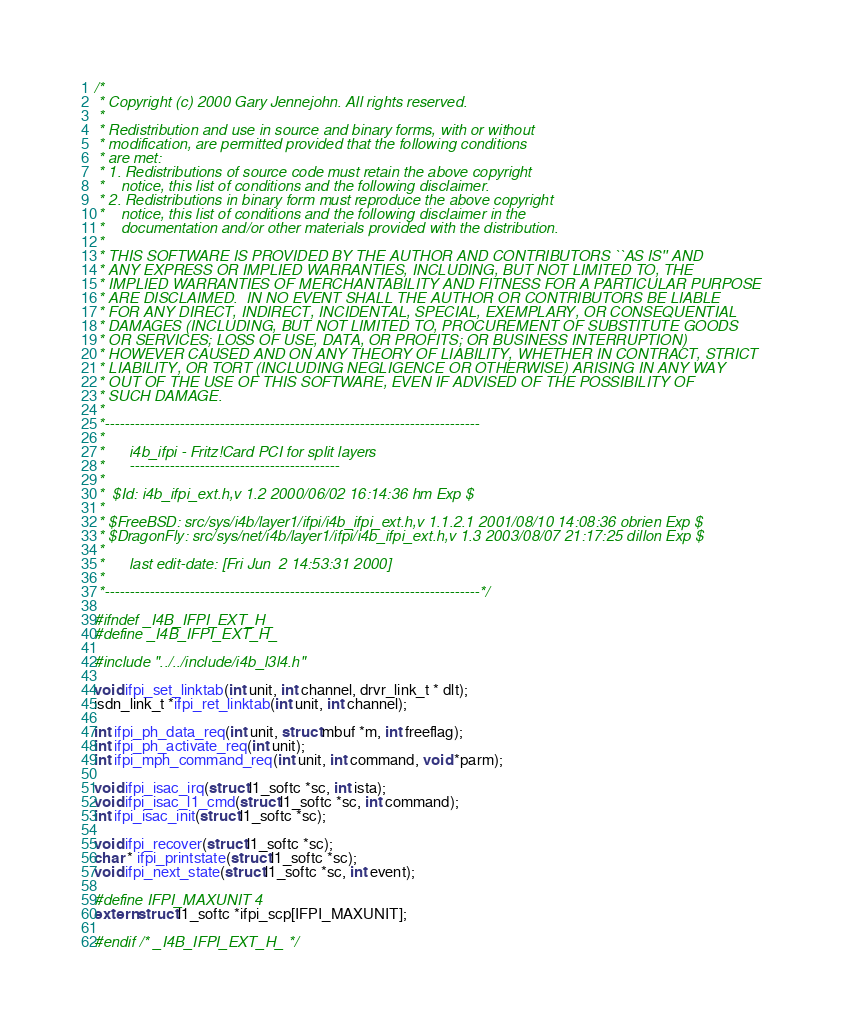Convert code to text. <code><loc_0><loc_0><loc_500><loc_500><_C_>/*
 * Copyright (c) 2000 Gary Jennejohn. All rights reserved.
 *
 * Redistribution and use in source and binary forms, with or without
 * modification, are permitted provided that the following conditions
 * are met:
 * 1. Redistributions of source code must retain the above copyright
 *    notice, this list of conditions and the following disclaimer.
 * 2. Redistributions in binary form must reproduce the above copyright
 *    notice, this list of conditions and the following disclaimer in the
 *    documentation and/or other materials provided with the distribution.
 *
 * THIS SOFTWARE IS PROVIDED BY THE AUTHOR AND CONTRIBUTORS ``AS IS'' AND
 * ANY EXPRESS OR IMPLIED WARRANTIES, INCLUDING, BUT NOT LIMITED TO, THE
 * IMPLIED WARRANTIES OF MERCHANTABILITY AND FITNESS FOR A PARTICULAR PURPOSE
 * ARE DISCLAIMED.  IN NO EVENT SHALL THE AUTHOR OR CONTRIBUTORS BE LIABLE
 * FOR ANY DIRECT, INDIRECT, INCIDENTAL, SPECIAL, EXEMPLARY, OR CONSEQUENTIAL
 * DAMAGES (INCLUDING, BUT NOT LIMITED TO, PROCUREMENT OF SUBSTITUTE GOODS
 * OR SERVICES; LOSS OF USE, DATA, OR PROFITS; OR BUSINESS INTERRUPTION)
 * HOWEVER CAUSED AND ON ANY THEORY OF LIABILITY, WHETHER IN CONTRACT, STRICT
 * LIABILITY, OR TORT (INCLUDING NEGLIGENCE OR OTHERWISE) ARISING IN ANY WAY
 * OUT OF THE USE OF THIS SOFTWARE, EVEN IF ADVISED OF THE POSSIBILITY OF
 * SUCH DAMAGE.
 *
 *---------------------------------------------------------------------------
 *
 *      i4b_ifpi - Fritz!Card PCI for split layers
 *      ------------------------------------------
 *
 *	$Id: i4b_ifpi_ext.h,v 1.2 2000/06/02 16:14:36 hm Exp $
 *
 * $FreeBSD: src/sys/i4b/layer1/ifpi/i4b_ifpi_ext.h,v 1.1.2.1 2001/08/10 14:08:36 obrien Exp $
 * $DragonFly: src/sys/net/i4b/layer1/ifpi/i4b_ifpi_ext.h,v 1.3 2003/08/07 21:17:25 dillon Exp $
 *
 *      last edit-date: [Fri Jun  2 14:53:31 2000]
 *
 *---------------------------------------------------------------------------*/

#ifndef _I4B_IFPI_EXT_H_
#define _I4B_IFPI_EXT_H_

#include "../../include/i4b_l3l4.h"

void ifpi_set_linktab(int unit, int channel, drvr_link_t * dlt);
isdn_link_t *ifpi_ret_linktab(int unit, int channel);

int ifpi_ph_data_req(int unit, struct mbuf *m, int freeflag);
int ifpi_ph_activate_req(int unit);
int ifpi_mph_command_req(int unit, int command, void *parm);

void ifpi_isac_irq(struct l1_softc *sc, int ista);
void ifpi_isac_l1_cmd(struct l1_softc *sc, int command);
int ifpi_isac_init(struct l1_softc *sc);

void ifpi_recover(struct l1_softc *sc);
char * ifpi_printstate(struct l1_softc *sc);
void ifpi_next_state(struct l1_softc *sc, int event);

#define IFPI_MAXUNIT 4
extern struct l1_softc *ifpi_scp[IFPI_MAXUNIT];

#endif /* _I4B_IFPI_EXT_H_ */
</code> 